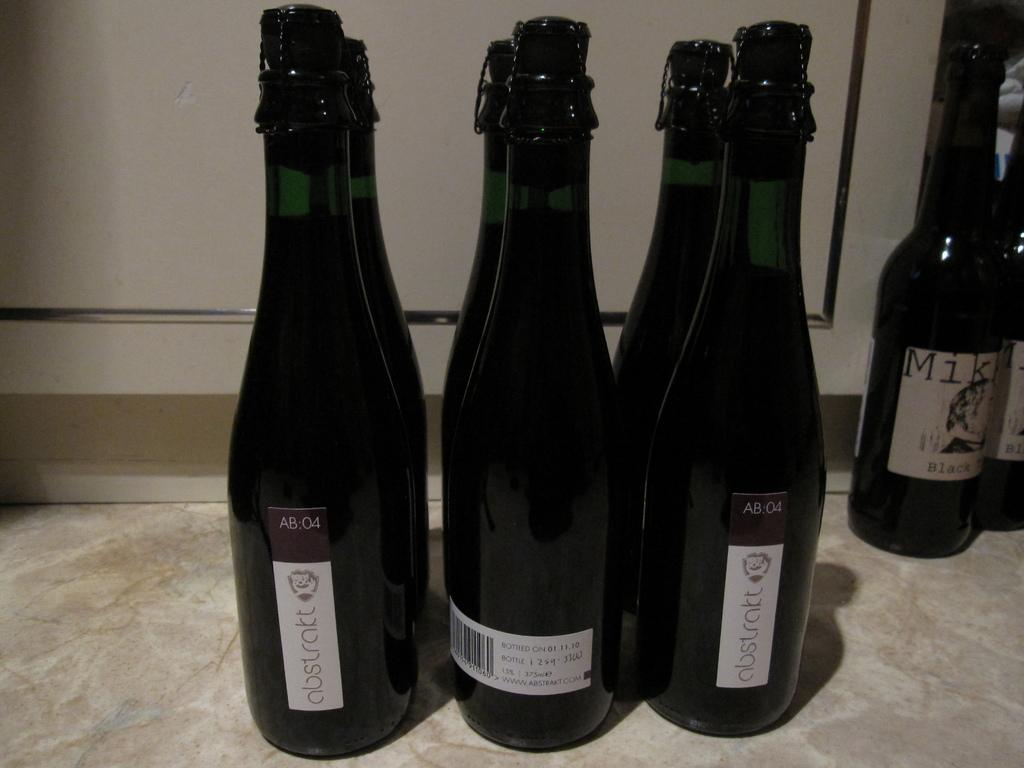What objects are on the floor in the image? There are bottles on the floor in the image. What can be found on the bottles? The bottles have labels on them. What information is provided on the labels? There is text written on the labels. What is visible behind the bottles? There is a wall behind the bottles. What invention is being demonstrated by the chickens in the image? There are no chickens present in the image, so it is not possible to determine if any invention is being demonstrated. 